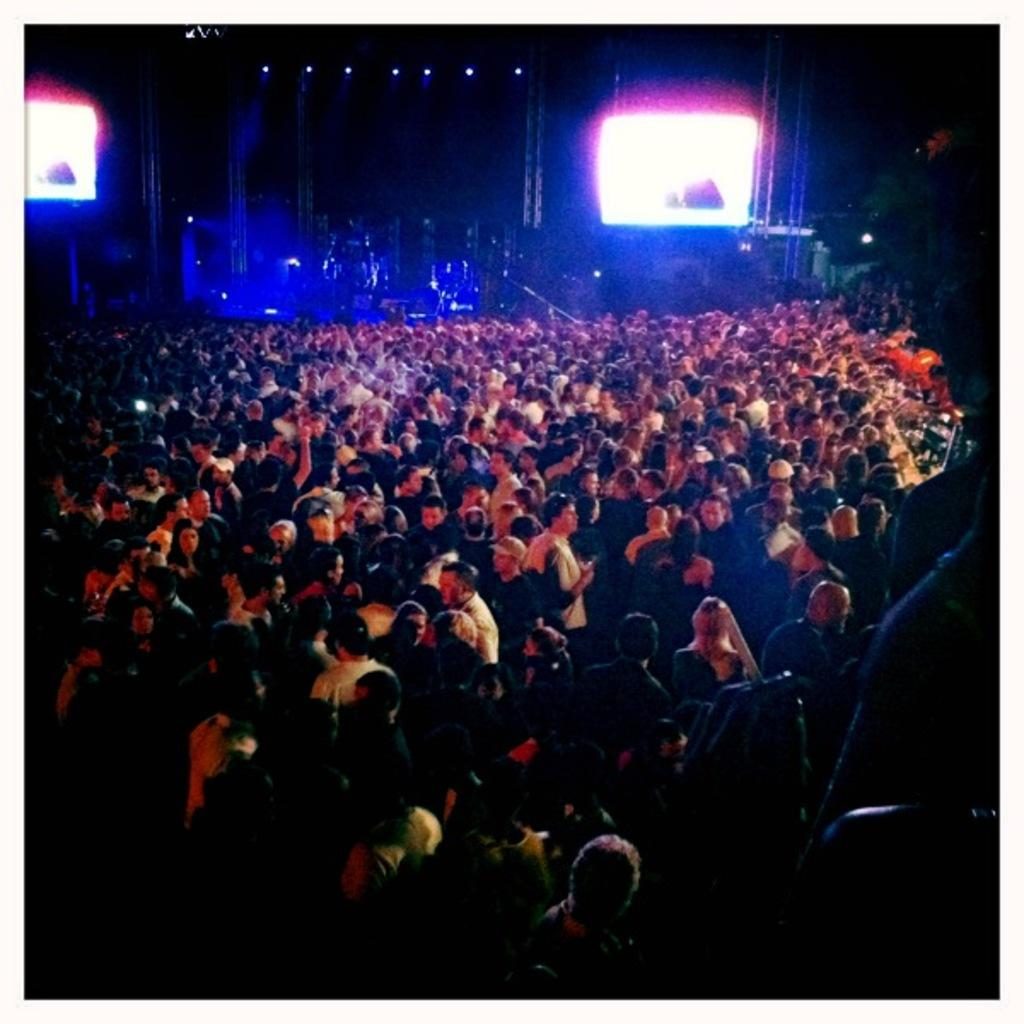How many people can be seen in the image? There are many people in the image. What is the color of the background in the image? The background of the image is dark. What can be seen on the screens in the background? The details of the screens are not visible, but they are present in the background. What type of lighting is present in the background? Lights are present in the background. What other objects can be seen in the background? Rods and other objects are present in the background. What type of bean is growing on the line in the image? There is no bean or line present in the image. Can you describe the grass in the image? There is no grass visible in the image. 